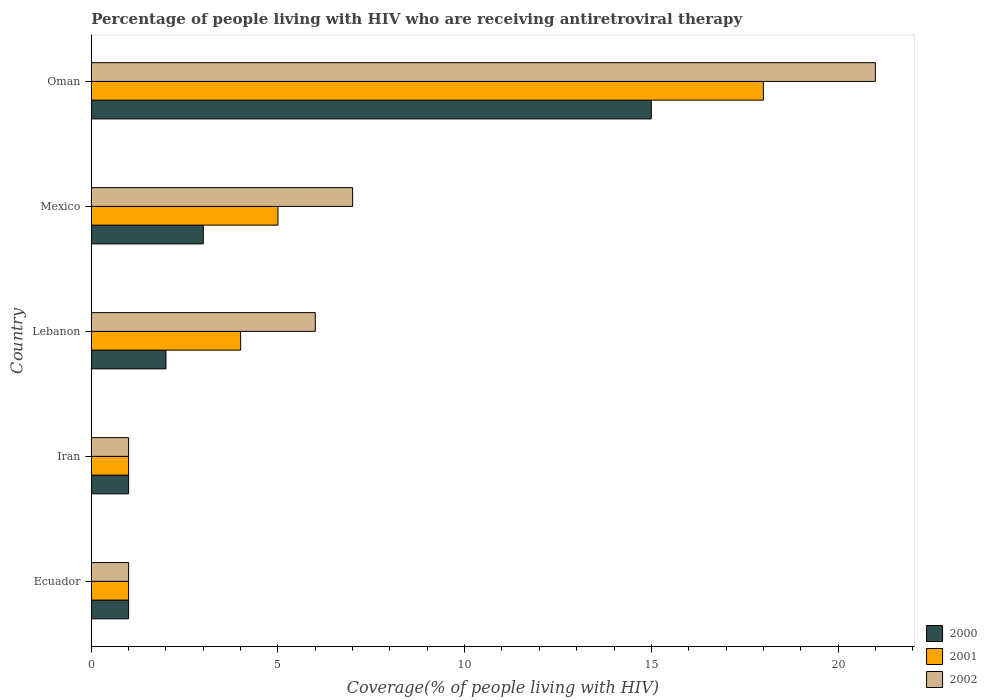How many groups of bars are there?
Give a very brief answer. 5. How many bars are there on the 1st tick from the bottom?
Keep it short and to the point. 3. What is the label of the 1st group of bars from the top?
Offer a very short reply. Oman. In how many cases, is the number of bars for a given country not equal to the number of legend labels?
Make the answer very short. 0. Across all countries, what is the minimum percentage of the HIV infected people who are receiving antiretroviral therapy in 2002?
Offer a terse response. 1. In which country was the percentage of the HIV infected people who are receiving antiretroviral therapy in 2002 maximum?
Your answer should be very brief. Oman. In which country was the percentage of the HIV infected people who are receiving antiretroviral therapy in 2002 minimum?
Provide a short and direct response. Ecuador. What is the total percentage of the HIV infected people who are receiving antiretroviral therapy in 2000 in the graph?
Your answer should be very brief. 22. What is the average percentage of the HIV infected people who are receiving antiretroviral therapy in 2000 per country?
Ensure brevity in your answer.  4.4. What is the ratio of the percentage of the HIV infected people who are receiving antiretroviral therapy in 2000 in Ecuador to that in Iran?
Ensure brevity in your answer.  1. Is the percentage of the HIV infected people who are receiving antiretroviral therapy in 2001 in Ecuador less than that in Iran?
Provide a succinct answer. No. Is the difference between the percentage of the HIV infected people who are receiving antiretroviral therapy in 2002 in Ecuador and Mexico greater than the difference between the percentage of the HIV infected people who are receiving antiretroviral therapy in 2001 in Ecuador and Mexico?
Provide a short and direct response. No. In how many countries, is the percentage of the HIV infected people who are receiving antiretroviral therapy in 2000 greater than the average percentage of the HIV infected people who are receiving antiretroviral therapy in 2000 taken over all countries?
Offer a terse response. 1. Is the sum of the percentage of the HIV infected people who are receiving antiretroviral therapy in 2002 in Iran and Oman greater than the maximum percentage of the HIV infected people who are receiving antiretroviral therapy in 2001 across all countries?
Provide a short and direct response. Yes. What does the 2nd bar from the top in Lebanon represents?
Ensure brevity in your answer.  2001. What does the 1st bar from the bottom in Oman represents?
Ensure brevity in your answer.  2000. Is it the case that in every country, the sum of the percentage of the HIV infected people who are receiving antiretroviral therapy in 2002 and percentage of the HIV infected people who are receiving antiretroviral therapy in 2000 is greater than the percentage of the HIV infected people who are receiving antiretroviral therapy in 2001?
Give a very brief answer. Yes. Are all the bars in the graph horizontal?
Keep it short and to the point. Yes. How many countries are there in the graph?
Provide a succinct answer. 5. What is the difference between two consecutive major ticks on the X-axis?
Give a very brief answer. 5. Are the values on the major ticks of X-axis written in scientific E-notation?
Your answer should be very brief. No. Does the graph contain grids?
Keep it short and to the point. No. What is the title of the graph?
Your response must be concise. Percentage of people living with HIV who are receiving antiretroviral therapy. Does "1983" appear as one of the legend labels in the graph?
Your answer should be very brief. No. What is the label or title of the X-axis?
Offer a very short reply. Coverage(% of people living with HIV). What is the label or title of the Y-axis?
Offer a very short reply. Country. What is the Coverage(% of people living with HIV) in 2001 in Ecuador?
Your answer should be very brief. 1. What is the Coverage(% of people living with HIV) of 2000 in Iran?
Your response must be concise. 1. What is the Coverage(% of people living with HIV) in 2000 in Lebanon?
Give a very brief answer. 2. What is the Coverage(% of people living with HIV) in 2001 in Lebanon?
Offer a very short reply. 4. What is the Coverage(% of people living with HIV) of 2002 in Lebanon?
Give a very brief answer. 6. What is the Coverage(% of people living with HIV) of 2000 in Mexico?
Ensure brevity in your answer.  3. What is the Coverage(% of people living with HIV) in 2000 in Oman?
Your answer should be compact. 15. What is the Coverage(% of people living with HIV) in 2002 in Oman?
Your answer should be very brief. 21. What is the total Coverage(% of people living with HIV) in 2000 in the graph?
Your answer should be very brief. 22. What is the total Coverage(% of people living with HIV) in 2001 in the graph?
Give a very brief answer. 29. What is the total Coverage(% of people living with HIV) in 2002 in the graph?
Your answer should be compact. 36. What is the difference between the Coverage(% of people living with HIV) in 2002 in Ecuador and that in Mexico?
Your answer should be very brief. -6. What is the difference between the Coverage(% of people living with HIV) in 2001 in Ecuador and that in Oman?
Your answer should be very brief. -17. What is the difference between the Coverage(% of people living with HIV) of 2000 in Iran and that in Lebanon?
Offer a very short reply. -1. What is the difference between the Coverage(% of people living with HIV) in 2001 in Iran and that in Lebanon?
Offer a terse response. -3. What is the difference between the Coverage(% of people living with HIV) in 2000 in Iran and that in Mexico?
Provide a succinct answer. -2. What is the difference between the Coverage(% of people living with HIV) of 2001 in Iran and that in Mexico?
Ensure brevity in your answer.  -4. What is the difference between the Coverage(% of people living with HIV) of 2002 in Iran and that in Mexico?
Give a very brief answer. -6. What is the difference between the Coverage(% of people living with HIV) of 2000 in Iran and that in Oman?
Your response must be concise. -14. What is the difference between the Coverage(% of people living with HIV) of 2001 in Iran and that in Oman?
Provide a short and direct response. -17. What is the difference between the Coverage(% of people living with HIV) in 2002 in Iran and that in Oman?
Keep it short and to the point. -20. What is the difference between the Coverage(% of people living with HIV) in 2000 in Lebanon and that in Mexico?
Provide a succinct answer. -1. What is the difference between the Coverage(% of people living with HIV) of 2001 in Lebanon and that in Oman?
Your answer should be very brief. -14. What is the difference between the Coverage(% of people living with HIV) in 2000 in Mexico and that in Oman?
Provide a short and direct response. -12. What is the difference between the Coverage(% of people living with HIV) in 2001 in Mexico and that in Oman?
Keep it short and to the point. -13. What is the difference between the Coverage(% of people living with HIV) in 2000 in Ecuador and the Coverage(% of people living with HIV) in 2001 in Iran?
Your answer should be very brief. 0. What is the difference between the Coverage(% of people living with HIV) of 2000 in Ecuador and the Coverage(% of people living with HIV) of 2002 in Iran?
Offer a very short reply. 0. What is the difference between the Coverage(% of people living with HIV) in 2001 in Ecuador and the Coverage(% of people living with HIV) in 2002 in Iran?
Offer a very short reply. 0. What is the difference between the Coverage(% of people living with HIV) of 2000 in Ecuador and the Coverage(% of people living with HIV) of 2001 in Lebanon?
Your answer should be compact. -3. What is the difference between the Coverage(% of people living with HIV) of 2001 in Ecuador and the Coverage(% of people living with HIV) of 2002 in Mexico?
Keep it short and to the point. -6. What is the difference between the Coverage(% of people living with HIV) of 2001 in Ecuador and the Coverage(% of people living with HIV) of 2002 in Oman?
Make the answer very short. -20. What is the difference between the Coverage(% of people living with HIV) in 2000 in Iran and the Coverage(% of people living with HIV) in 2001 in Lebanon?
Provide a succinct answer. -3. What is the difference between the Coverage(% of people living with HIV) in 2001 in Iran and the Coverage(% of people living with HIV) in 2002 in Lebanon?
Your answer should be compact. -5. What is the difference between the Coverage(% of people living with HIV) of 2000 in Lebanon and the Coverage(% of people living with HIV) of 2001 in Mexico?
Ensure brevity in your answer.  -3. What is the difference between the Coverage(% of people living with HIV) of 2000 in Lebanon and the Coverage(% of people living with HIV) of 2002 in Mexico?
Make the answer very short. -5. What is the difference between the Coverage(% of people living with HIV) of 2001 in Lebanon and the Coverage(% of people living with HIV) of 2002 in Mexico?
Your response must be concise. -3. What is the difference between the Coverage(% of people living with HIV) in 2000 in Lebanon and the Coverage(% of people living with HIV) in 2001 in Oman?
Provide a succinct answer. -16. What is the difference between the Coverage(% of people living with HIV) of 2000 in Lebanon and the Coverage(% of people living with HIV) of 2002 in Oman?
Ensure brevity in your answer.  -19. What is the difference between the Coverage(% of people living with HIV) in 2001 in Lebanon and the Coverage(% of people living with HIV) in 2002 in Oman?
Keep it short and to the point. -17. What is the difference between the Coverage(% of people living with HIV) in 2000 and Coverage(% of people living with HIV) in 2001 in Ecuador?
Provide a succinct answer. 0. What is the difference between the Coverage(% of people living with HIV) in 2001 and Coverage(% of people living with HIV) in 2002 in Ecuador?
Provide a succinct answer. 0. What is the difference between the Coverage(% of people living with HIV) of 2000 and Coverage(% of people living with HIV) of 2001 in Iran?
Your response must be concise. 0. What is the difference between the Coverage(% of people living with HIV) in 2001 and Coverage(% of people living with HIV) in 2002 in Iran?
Your answer should be very brief. 0. What is the difference between the Coverage(% of people living with HIV) in 2000 and Coverage(% of people living with HIV) in 2001 in Lebanon?
Your answer should be very brief. -2. What is the difference between the Coverage(% of people living with HIV) of 2000 and Coverage(% of people living with HIV) of 2002 in Lebanon?
Your answer should be very brief. -4. What is the difference between the Coverage(% of people living with HIV) in 2000 and Coverage(% of people living with HIV) in 2001 in Mexico?
Ensure brevity in your answer.  -2. What is the difference between the Coverage(% of people living with HIV) in 2000 and Coverage(% of people living with HIV) in 2002 in Mexico?
Keep it short and to the point. -4. What is the difference between the Coverage(% of people living with HIV) of 2001 and Coverage(% of people living with HIV) of 2002 in Oman?
Give a very brief answer. -3. What is the ratio of the Coverage(% of people living with HIV) of 2000 in Ecuador to that in Lebanon?
Keep it short and to the point. 0.5. What is the ratio of the Coverage(% of people living with HIV) of 2002 in Ecuador to that in Lebanon?
Offer a very short reply. 0.17. What is the ratio of the Coverage(% of people living with HIV) of 2000 in Ecuador to that in Mexico?
Your answer should be compact. 0.33. What is the ratio of the Coverage(% of people living with HIV) in 2001 in Ecuador to that in Mexico?
Your answer should be compact. 0.2. What is the ratio of the Coverage(% of people living with HIV) in 2002 in Ecuador to that in Mexico?
Offer a terse response. 0.14. What is the ratio of the Coverage(% of people living with HIV) of 2000 in Ecuador to that in Oman?
Offer a very short reply. 0.07. What is the ratio of the Coverage(% of people living with HIV) of 2001 in Ecuador to that in Oman?
Keep it short and to the point. 0.06. What is the ratio of the Coverage(% of people living with HIV) in 2002 in Ecuador to that in Oman?
Your response must be concise. 0.05. What is the ratio of the Coverage(% of people living with HIV) in 2000 in Iran to that in Lebanon?
Ensure brevity in your answer.  0.5. What is the ratio of the Coverage(% of people living with HIV) of 2000 in Iran to that in Mexico?
Offer a terse response. 0.33. What is the ratio of the Coverage(% of people living with HIV) of 2002 in Iran to that in Mexico?
Your response must be concise. 0.14. What is the ratio of the Coverage(% of people living with HIV) of 2000 in Iran to that in Oman?
Your answer should be compact. 0.07. What is the ratio of the Coverage(% of people living with HIV) of 2001 in Iran to that in Oman?
Give a very brief answer. 0.06. What is the ratio of the Coverage(% of people living with HIV) in 2002 in Iran to that in Oman?
Offer a terse response. 0.05. What is the ratio of the Coverage(% of people living with HIV) of 2002 in Lebanon to that in Mexico?
Make the answer very short. 0.86. What is the ratio of the Coverage(% of people living with HIV) of 2000 in Lebanon to that in Oman?
Your answer should be very brief. 0.13. What is the ratio of the Coverage(% of people living with HIV) of 2001 in Lebanon to that in Oman?
Your answer should be very brief. 0.22. What is the ratio of the Coverage(% of people living with HIV) of 2002 in Lebanon to that in Oman?
Provide a short and direct response. 0.29. What is the ratio of the Coverage(% of people living with HIV) of 2001 in Mexico to that in Oman?
Offer a terse response. 0.28. What is the difference between the highest and the lowest Coverage(% of people living with HIV) of 2000?
Your response must be concise. 14. What is the difference between the highest and the lowest Coverage(% of people living with HIV) in 2001?
Your answer should be compact. 17. 